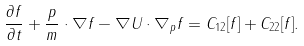Convert formula to latex. <formula><loc_0><loc_0><loc_500><loc_500>\frac { \partial f } { \partial t } + \frac { p } { m } \cdot \nabla f - \nabla U \cdot \nabla _ { p } f = C _ { 1 2 } [ f ] + C _ { 2 2 } [ f ] .</formula> 